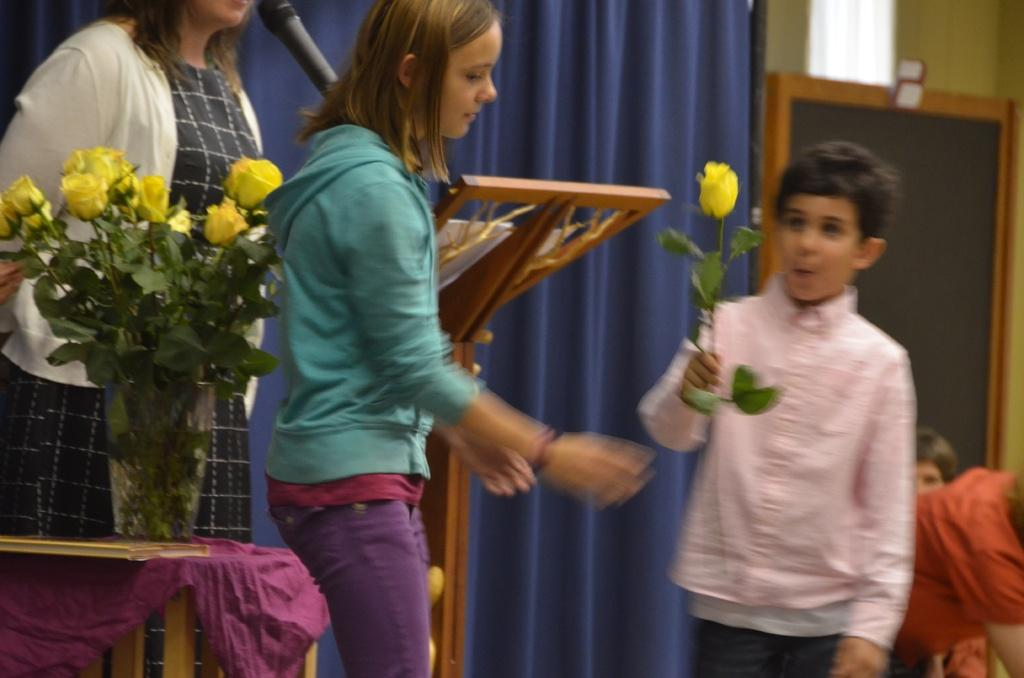How many people are in the image? There are three persons in the image. What can be seen on the left side of the image? There are flowers on the left side of the image. Where is the boy located in the image? The boy is on the right side of the image. What is the boy holding in the image? The boy is holding a flower. What object is at the top of the image? There is a mic at the top of the image. What type of watch is the boy wearing in the image? There is no watch visible on the boy in the image. Can you see any stars in the image? There are no stars present in the image. 